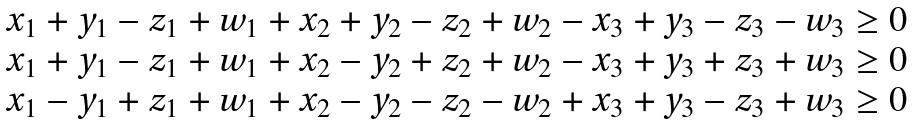Convert formula to latex. <formula><loc_0><loc_0><loc_500><loc_500>\begin{array} { c } x _ { 1 } + y _ { 1 } - z _ { 1 } + w _ { 1 } + x _ { 2 } + y _ { 2 } - z _ { 2 } + w _ { 2 } - x _ { 3 } + y _ { 3 } - z _ { 3 } - w _ { 3 } \geq 0 \\ x _ { 1 } + y _ { 1 } - z _ { 1 } + w _ { 1 } + x _ { 2 } - y _ { 2 } + z _ { 2 } + w _ { 2 } - x _ { 3 } + y _ { 3 } + z _ { 3 } + w _ { 3 } \geq 0 \\ x _ { 1 } - y _ { 1 } + z _ { 1 } + w _ { 1 } + x _ { 2 } - y _ { 2 } - z _ { 2 } - w _ { 2 } + x _ { 3 } + y _ { 3 } - z _ { 3 } + w _ { 3 } \geq 0 \end{array}</formula> 